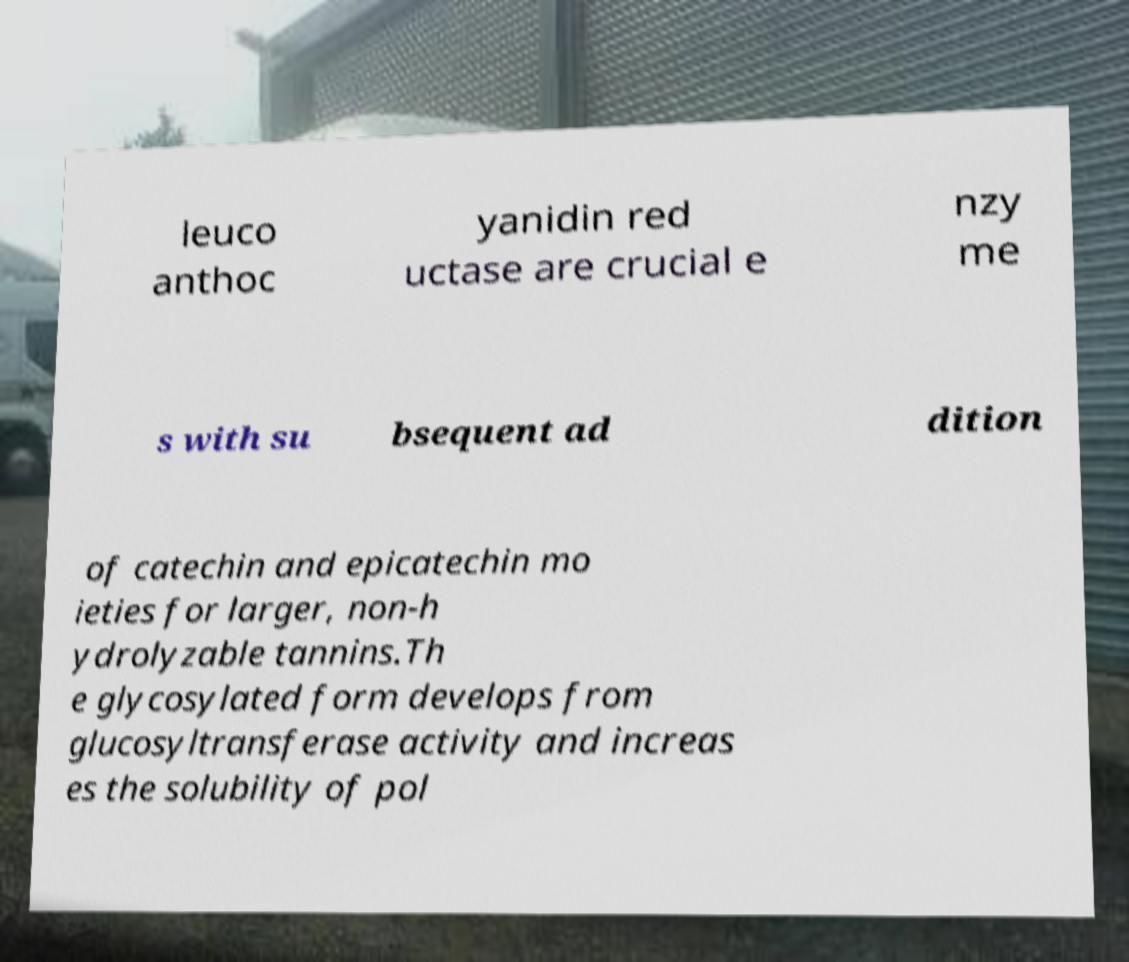Please read and relay the text visible in this image. What does it say? leuco anthoc yanidin red uctase are crucial e nzy me s with su bsequent ad dition of catechin and epicatechin mo ieties for larger, non-h ydrolyzable tannins.Th e glycosylated form develops from glucosyltransferase activity and increas es the solubility of pol 